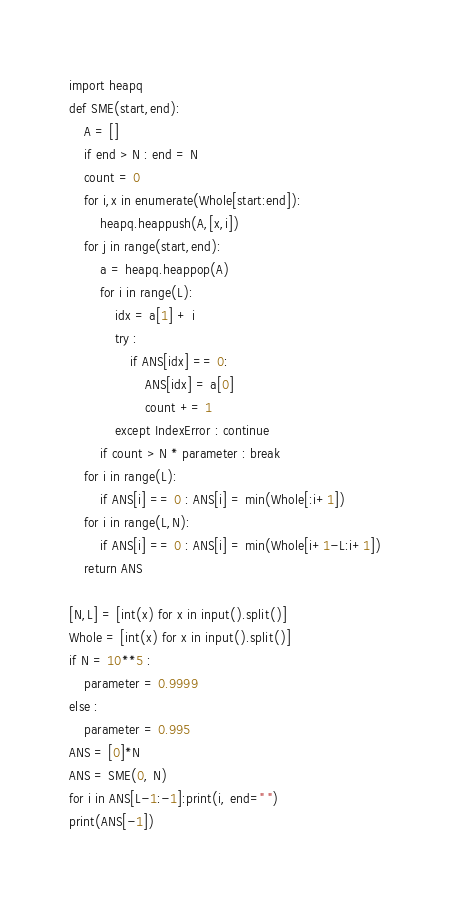<code> <loc_0><loc_0><loc_500><loc_500><_Python_>import heapq
def SME(start,end):
    A = []
    if end > N : end = N
    count = 0
    for i,x in enumerate(Whole[start:end]):
        heapq.heappush(A,[x,i])
    for j in range(start,end):
        a = heapq.heappop(A)
        for i in range(L):
            idx = a[1] + i
            try :
                if ANS[idx] == 0:
                    ANS[idx] = a[0]
                    count += 1
            except IndexError : continue
        if count > N * parameter : break
    for i in range(L):
        if ANS[i] == 0 : ANS[i] = min(Whole[:i+1])
    for i in range(L,N):
        if ANS[i] == 0 : ANS[i] = min(Whole[i+1-L:i+1])
    return ANS

[N,L] = [int(x) for x in input().split()]
Whole = [int(x) for x in input().split()]
if N = 10**5 :
    parameter = 0.9999
else :
    parameter = 0.995
ANS = [0]*N
ANS = SME(0, N)
for i in ANS[L-1:-1]:print(i, end=" ")
print(ANS[-1])</code> 